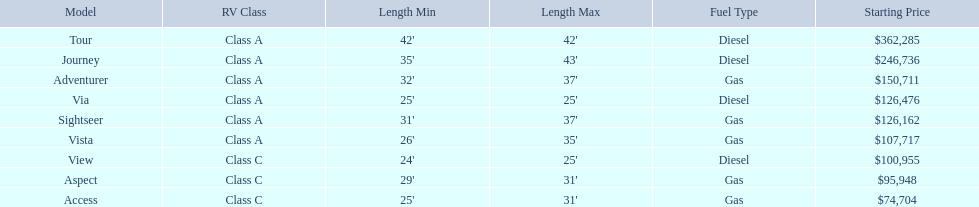What are all of the winnebago models? Tour, Journey, Adventurer, Via, Sightseer, Vista, View, Aspect, Access. What are their prices? $362,285, $246,736, $150,711, $126,476, $126,162, $107,717, $100,955, $95,948, $74,704. And which model costs the most? Tour. 